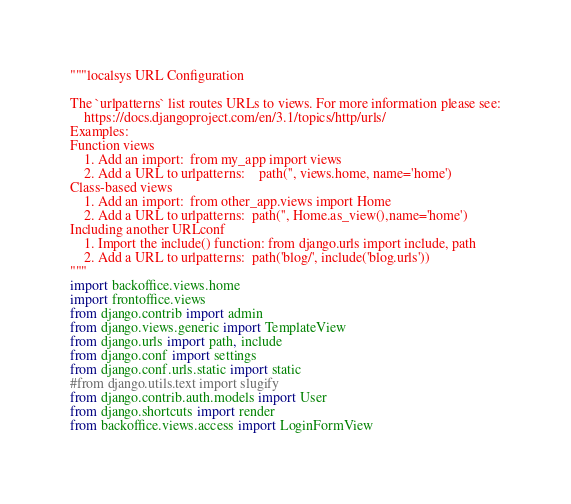Convert code to text. <code><loc_0><loc_0><loc_500><loc_500><_Python_>"""localsys URL Configuration

The `urlpatterns` list routes URLs to views. For more information please see:
    https://docs.djangoproject.com/en/3.1/topics/http/urls/
Examples:
Function views
    1. Add an import:  from my_app import views
    2. Add a URL to urlpatterns:    path('', views.home, name='home')
Class-based views
    1. Add an import:  from other_app.views import Home
    2. Add a URL to urlpatterns:  path('', Home.as_view(),name='home')
Including another URLconf
    1. Import the include() function: from django.urls import include, path
    2. Add a URL to urlpatterns:  path('blog/', include('blog.urls'))
"""
import backoffice.views.home
import frontoffice.views
from django.contrib import admin
from django.views.generic import TemplateView
from django.urls import path, include
from django.conf import settings
from django.conf.urls.static import static
#from django.utils.text import slugify
from django.contrib.auth.models import User
from django.shortcuts import render
from backoffice.views.access import LoginFormView</code> 